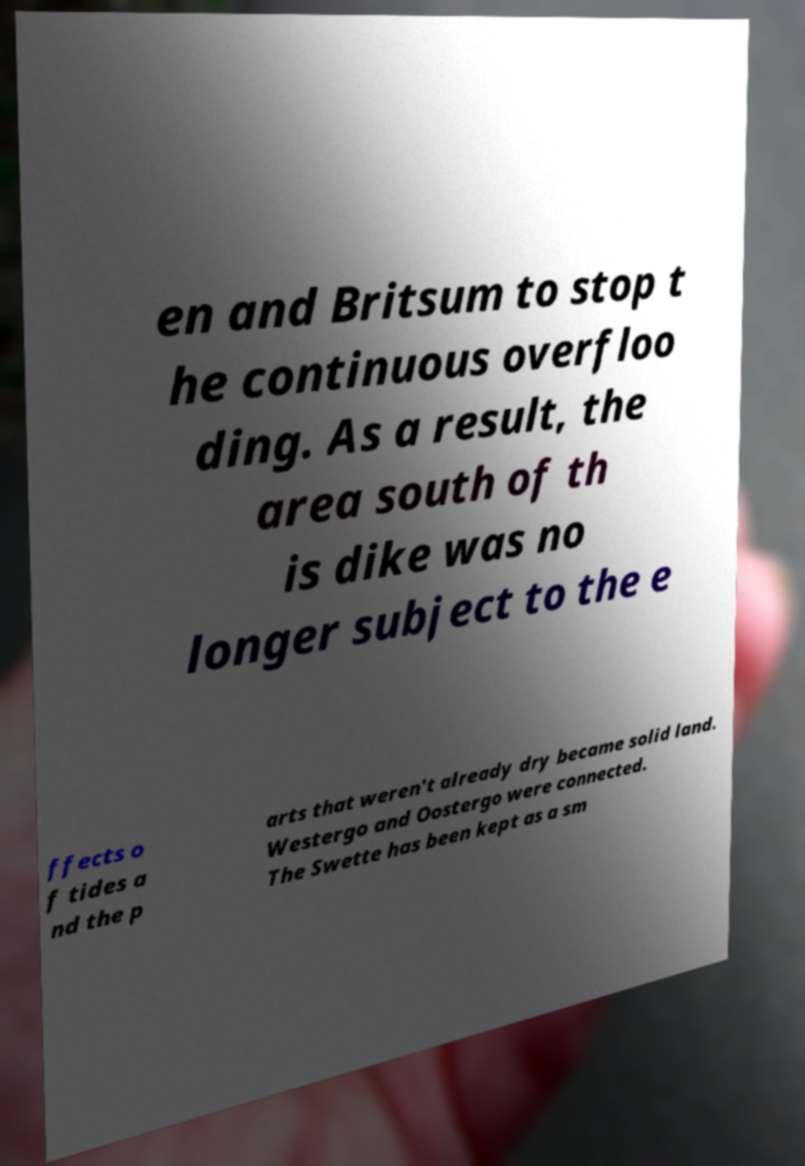Could you assist in decoding the text presented in this image and type it out clearly? en and Britsum to stop t he continuous overfloo ding. As a result, the area south of th is dike was no longer subject to the e ffects o f tides a nd the p arts that weren't already dry became solid land. Westergo and Oostergo were connected. The Swette has been kept as a sm 